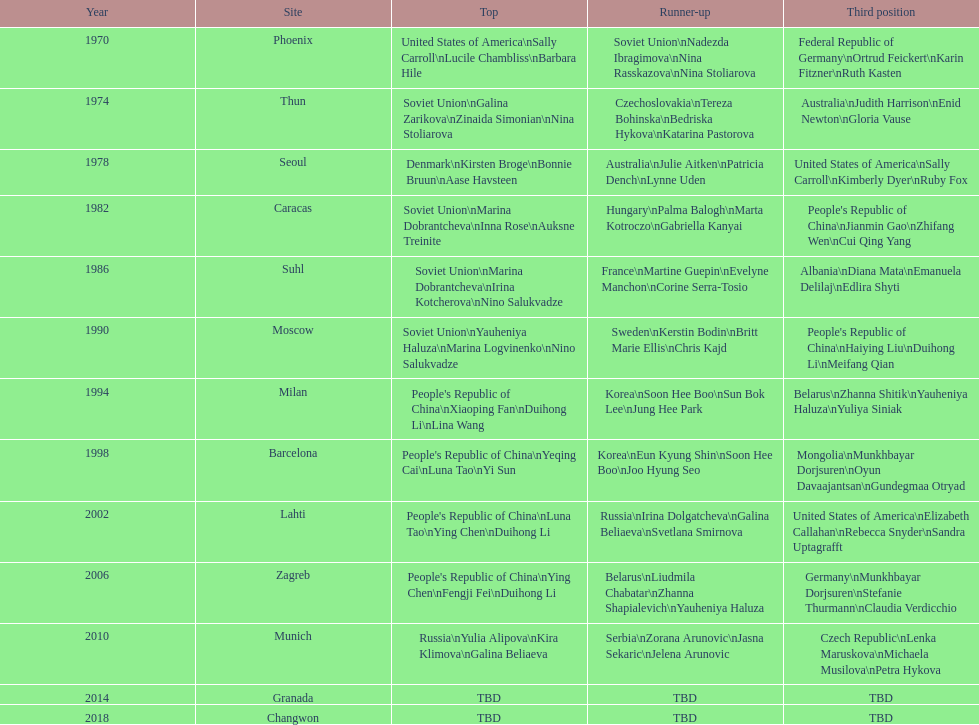What are the total number of times the soviet union is listed under the gold column? 4. 